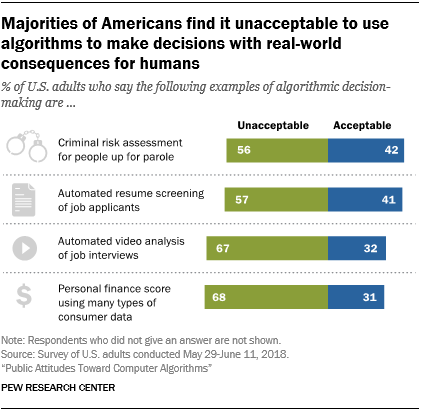Indicate a few pertinent items in this graphic. The lowest value of the green bar is not 57. The average of blue bars is smaller than the median of green bars. 